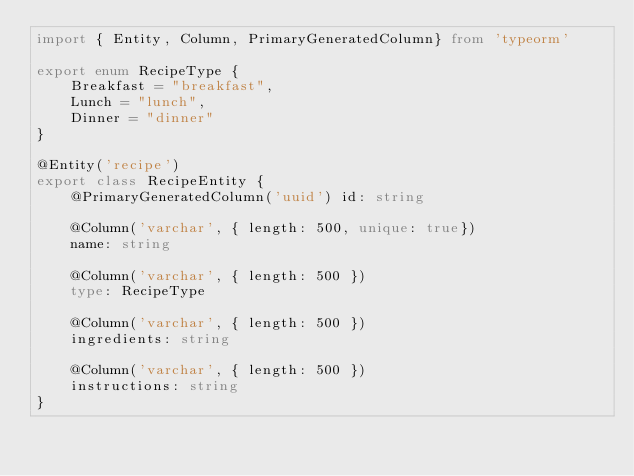Convert code to text. <code><loc_0><loc_0><loc_500><loc_500><_TypeScript_>import { Entity, Column, PrimaryGeneratedColumn} from 'typeorm'

export enum RecipeType {
    Breakfast = "breakfast",
    Lunch = "lunch",
    Dinner = "dinner"
}

@Entity('recipe')
export class RecipeEntity {
	@PrimaryGeneratedColumn('uuid') id: string

    @Column('varchar', { length: 500, unique: true})
    name: string

    @Column('varchar', { length: 500 })
    type: RecipeType

    @Column('varchar', { length: 500 })
    ingredients: string

    @Column('varchar', { length: 500 })
    instructions: string
}</code> 